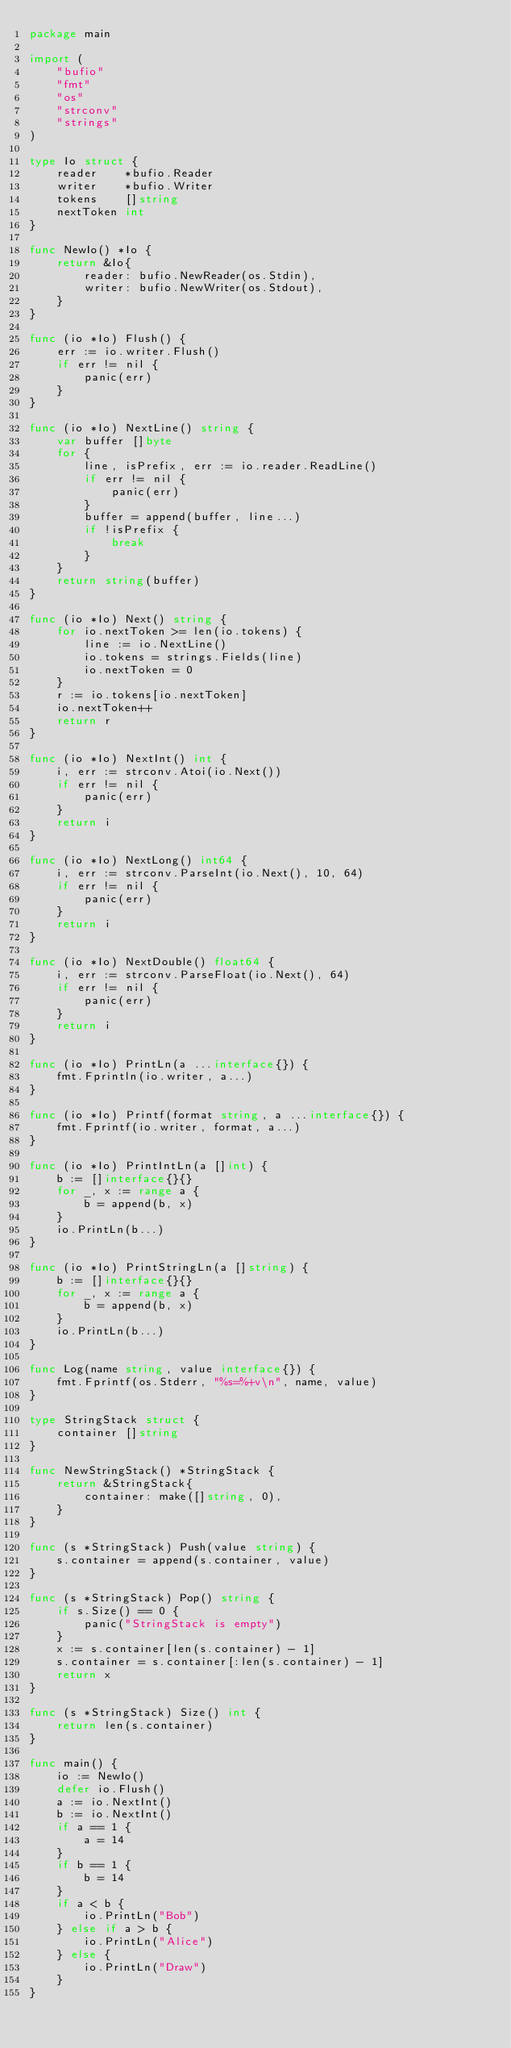Convert code to text. <code><loc_0><loc_0><loc_500><loc_500><_Go_>package main

import (
	"bufio"
	"fmt"
	"os"
	"strconv"
	"strings"
)

type Io struct {
	reader    *bufio.Reader
	writer    *bufio.Writer
	tokens    []string
	nextToken int
}

func NewIo() *Io {
	return &Io{
		reader: bufio.NewReader(os.Stdin),
		writer: bufio.NewWriter(os.Stdout),
	}
}

func (io *Io) Flush() {
	err := io.writer.Flush()
	if err != nil {
		panic(err)
	}
}

func (io *Io) NextLine() string {
	var buffer []byte
	for {
		line, isPrefix, err := io.reader.ReadLine()
		if err != nil {
			panic(err)
		}
		buffer = append(buffer, line...)
		if !isPrefix {
			break
		}
	}
	return string(buffer)
}

func (io *Io) Next() string {
	for io.nextToken >= len(io.tokens) {
		line := io.NextLine()
		io.tokens = strings.Fields(line)
		io.nextToken = 0
	}
	r := io.tokens[io.nextToken]
	io.nextToken++
	return r
}

func (io *Io) NextInt() int {
	i, err := strconv.Atoi(io.Next())
	if err != nil {
		panic(err)
	}
	return i
}

func (io *Io) NextLong() int64 {
	i, err := strconv.ParseInt(io.Next(), 10, 64)
	if err != nil {
		panic(err)
	}
	return i
}

func (io *Io) NextDouble() float64 {
	i, err := strconv.ParseFloat(io.Next(), 64)
	if err != nil {
		panic(err)
	}
	return i
}

func (io *Io) PrintLn(a ...interface{}) {
	fmt.Fprintln(io.writer, a...)
}

func (io *Io) Printf(format string, a ...interface{}) {
	fmt.Fprintf(io.writer, format, a...)
}

func (io *Io) PrintIntLn(a []int) {
	b := []interface{}{}
	for _, x := range a {
		b = append(b, x)
	}
	io.PrintLn(b...)
}

func (io *Io) PrintStringLn(a []string) {
	b := []interface{}{}
	for _, x := range a {
		b = append(b, x)
	}
	io.PrintLn(b...)
}

func Log(name string, value interface{}) {
	fmt.Fprintf(os.Stderr, "%s=%+v\n", name, value)
}

type StringStack struct {
	container []string
}

func NewStringStack() *StringStack {
	return &StringStack{
		container: make([]string, 0),
	}
}

func (s *StringStack) Push(value string) {
	s.container = append(s.container, value)
}

func (s *StringStack) Pop() string {
	if s.Size() == 0 {
		panic("StringStack is empty")
	}
	x := s.container[len(s.container) - 1]
	s.container = s.container[:len(s.container) - 1]
	return x
}

func (s *StringStack) Size() int {
	return len(s.container)
}

func main() {
	io := NewIo()
	defer io.Flush()
	a := io.NextInt()
	b := io.NextInt()
	if a == 1 {
		a = 14
	}
	if b == 1 {
		b = 14
	}
	if a < b {
		io.PrintLn("Bob")
	} else if a > b {
		io.PrintLn("Alice")
	} else {
		io.PrintLn("Draw")
	}
}</code> 